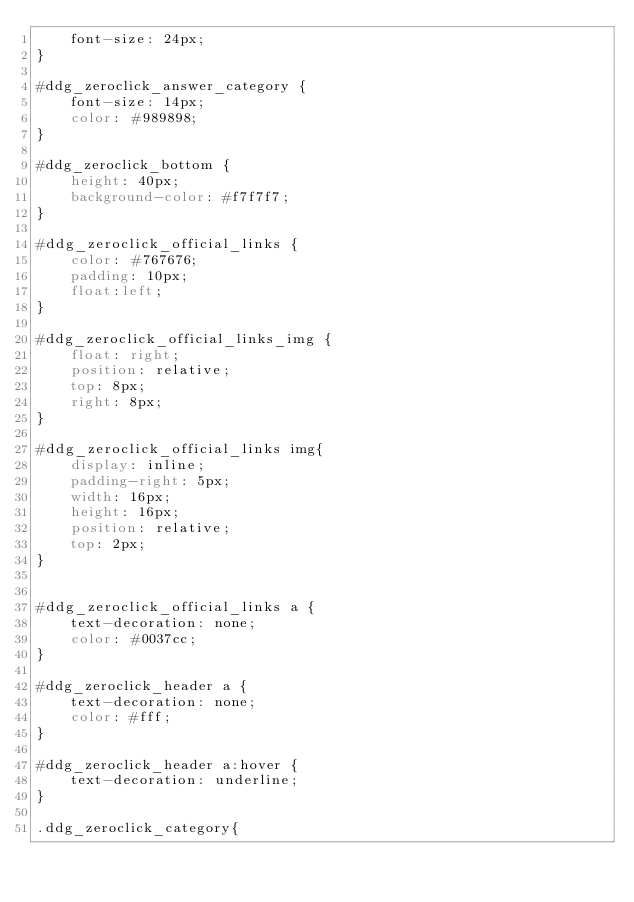<code> <loc_0><loc_0><loc_500><loc_500><_CSS_>    font-size: 24px;
}

#ddg_zeroclick_answer_category {
    font-size: 14px;
    color: #989898;
}

#ddg_zeroclick_bottom {
    height: 40px;
    background-color: #f7f7f7;
}

#ddg_zeroclick_official_links {
    color: #767676;
    padding: 10px;
    float:left;
}

#ddg_zeroclick_official_links_img {
    float: right;
    position: relative;
    top: 8px;
    right: 8px;
}

#ddg_zeroclick_official_links img{
    display: inline;
    padding-right: 5px;
    width: 16px;
    height: 16px;
    position: relative;
    top: 2px;
}


#ddg_zeroclick_official_links a {
    text-decoration: none;
    color: #0037cc;
}

#ddg_zeroclick_header a {
    text-decoration: none;
    color: #fff;
}

#ddg_zeroclick_header a:hover {
    text-decoration: underline;
}

.ddg_zeroclick_category{</code> 